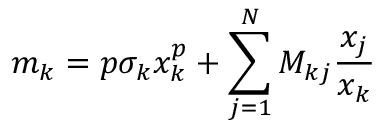Convert formula to latex. <formula><loc_0><loc_0><loc_500><loc_500>m _ { k } = p \sigma _ { k } x _ { k } ^ { p } + \sum _ { j = 1 } ^ { N } M _ { k j } \frac { x _ { j } } { x _ { k } }</formula> 